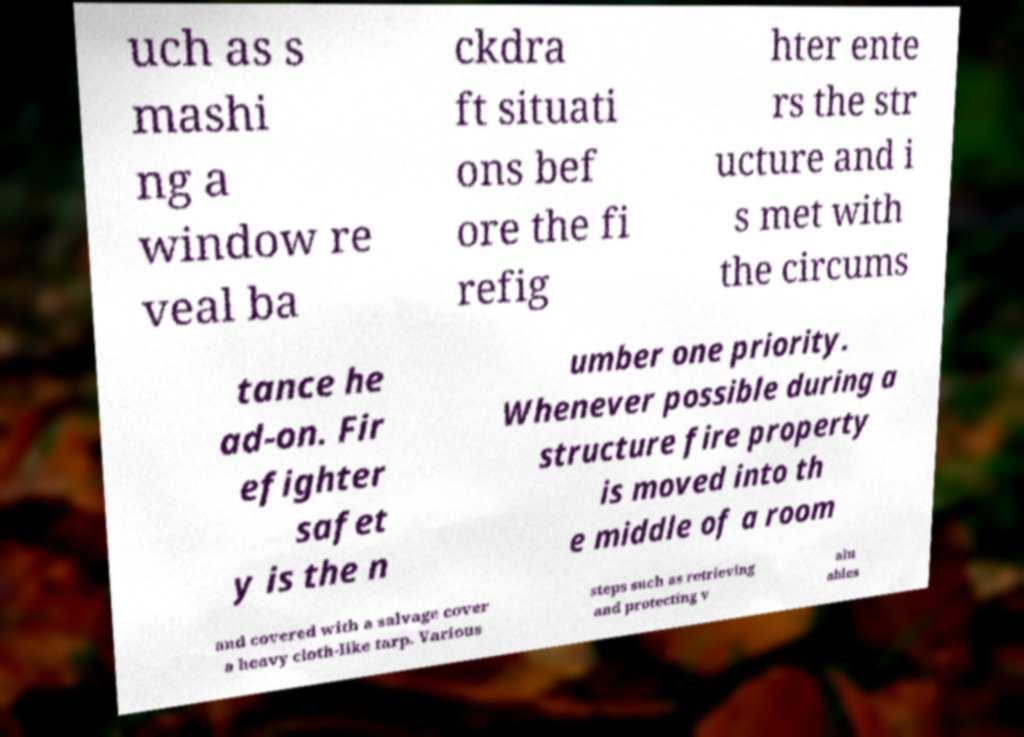Please identify and transcribe the text found in this image. uch as s mashi ng a window re veal ba ckdra ft situati ons bef ore the fi refig hter ente rs the str ucture and i s met with the circums tance he ad-on. Fir efighter safet y is the n umber one priority. Whenever possible during a structure fire property is moved into th e middle of a room and covered with a salvage cover a heavy cloth-like tarp. Various steps such as retrieving and protecting v alu ables 